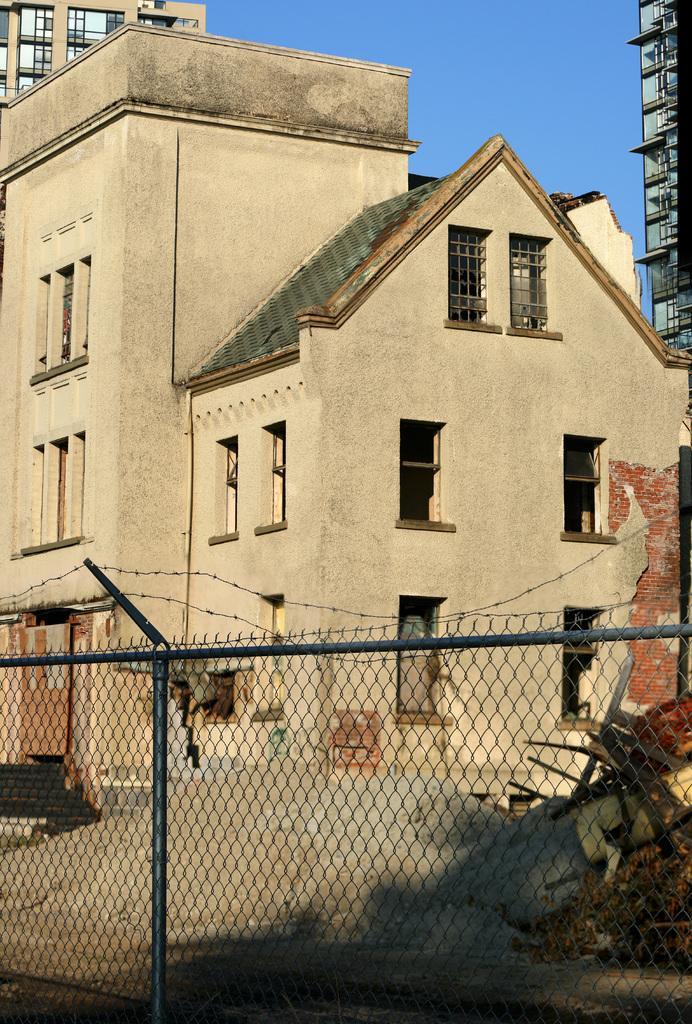How would you summarize this image in a sentence or two? In this image we can see the buildings and we can see the sand and few objects on the ground. In front of the building we can see a fence. In the background, we can see the sky. 